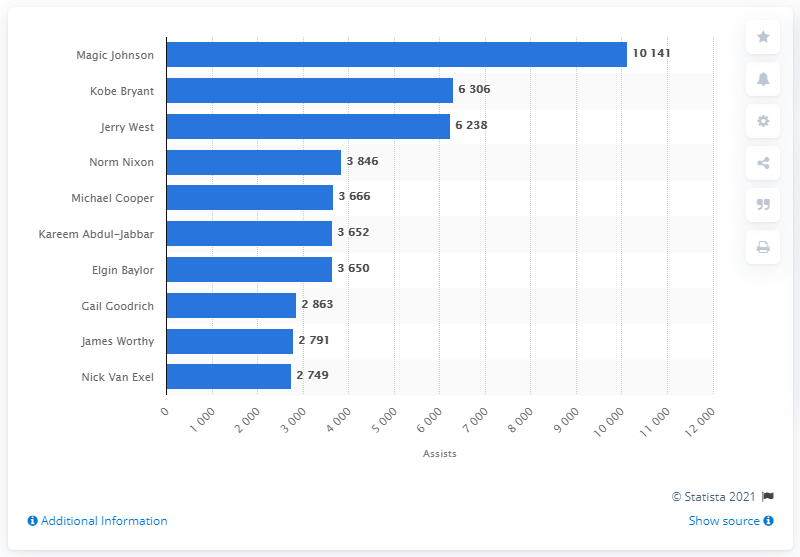List a handful of essential elements in this visual. Magic Johnson is the career assists leader for the Los Angeles Lakers. 